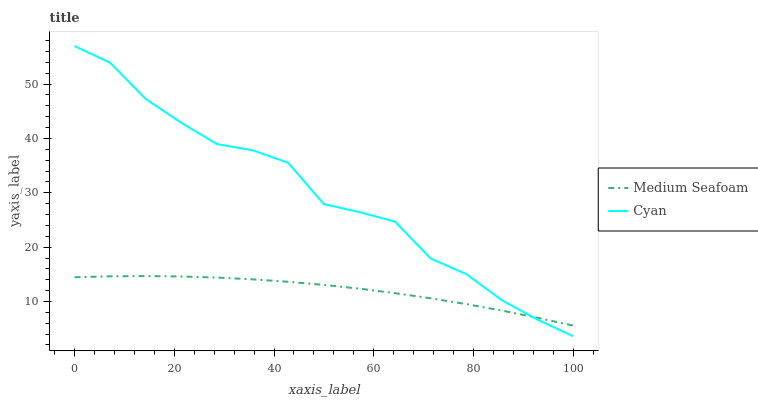Does Medium Seafoam have the minimum area under the curve?
Answer yes or no. Yes. Does Cyan have the maximum area under the curve?
Answer yes or no. Yes. Does Medium Seafoam have the maximum area under the curve?
Answer yes or no. No. Is Medium Seafoam the smoothest?
Answer yes or no. Yes. Is Cyan the roughest?
Answer yes or no. Yes. Is Medium Seafoam the roughest?
Answer yes or no. No. Does Medium Seafoam have the lowest value?
Answer yes or no. No. Does Medium Seafoam have the highest value?
Answer yes or no. No. 